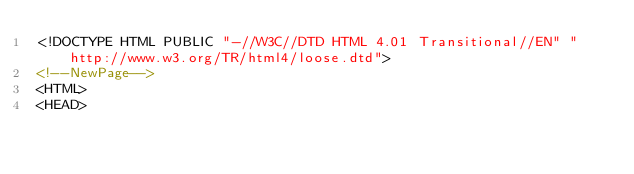<code> <loc_0><loc_0><loc_500><loc_500><_HTML_><!DOCTYPE HTML PUBLIC "-//W3C//DTD HTML 4.01 Transitional//EN" "http://www.w3.org/TR/html4/loose.dtd">
<!--NewPage-->
<HTML>
<HEAD></code> 